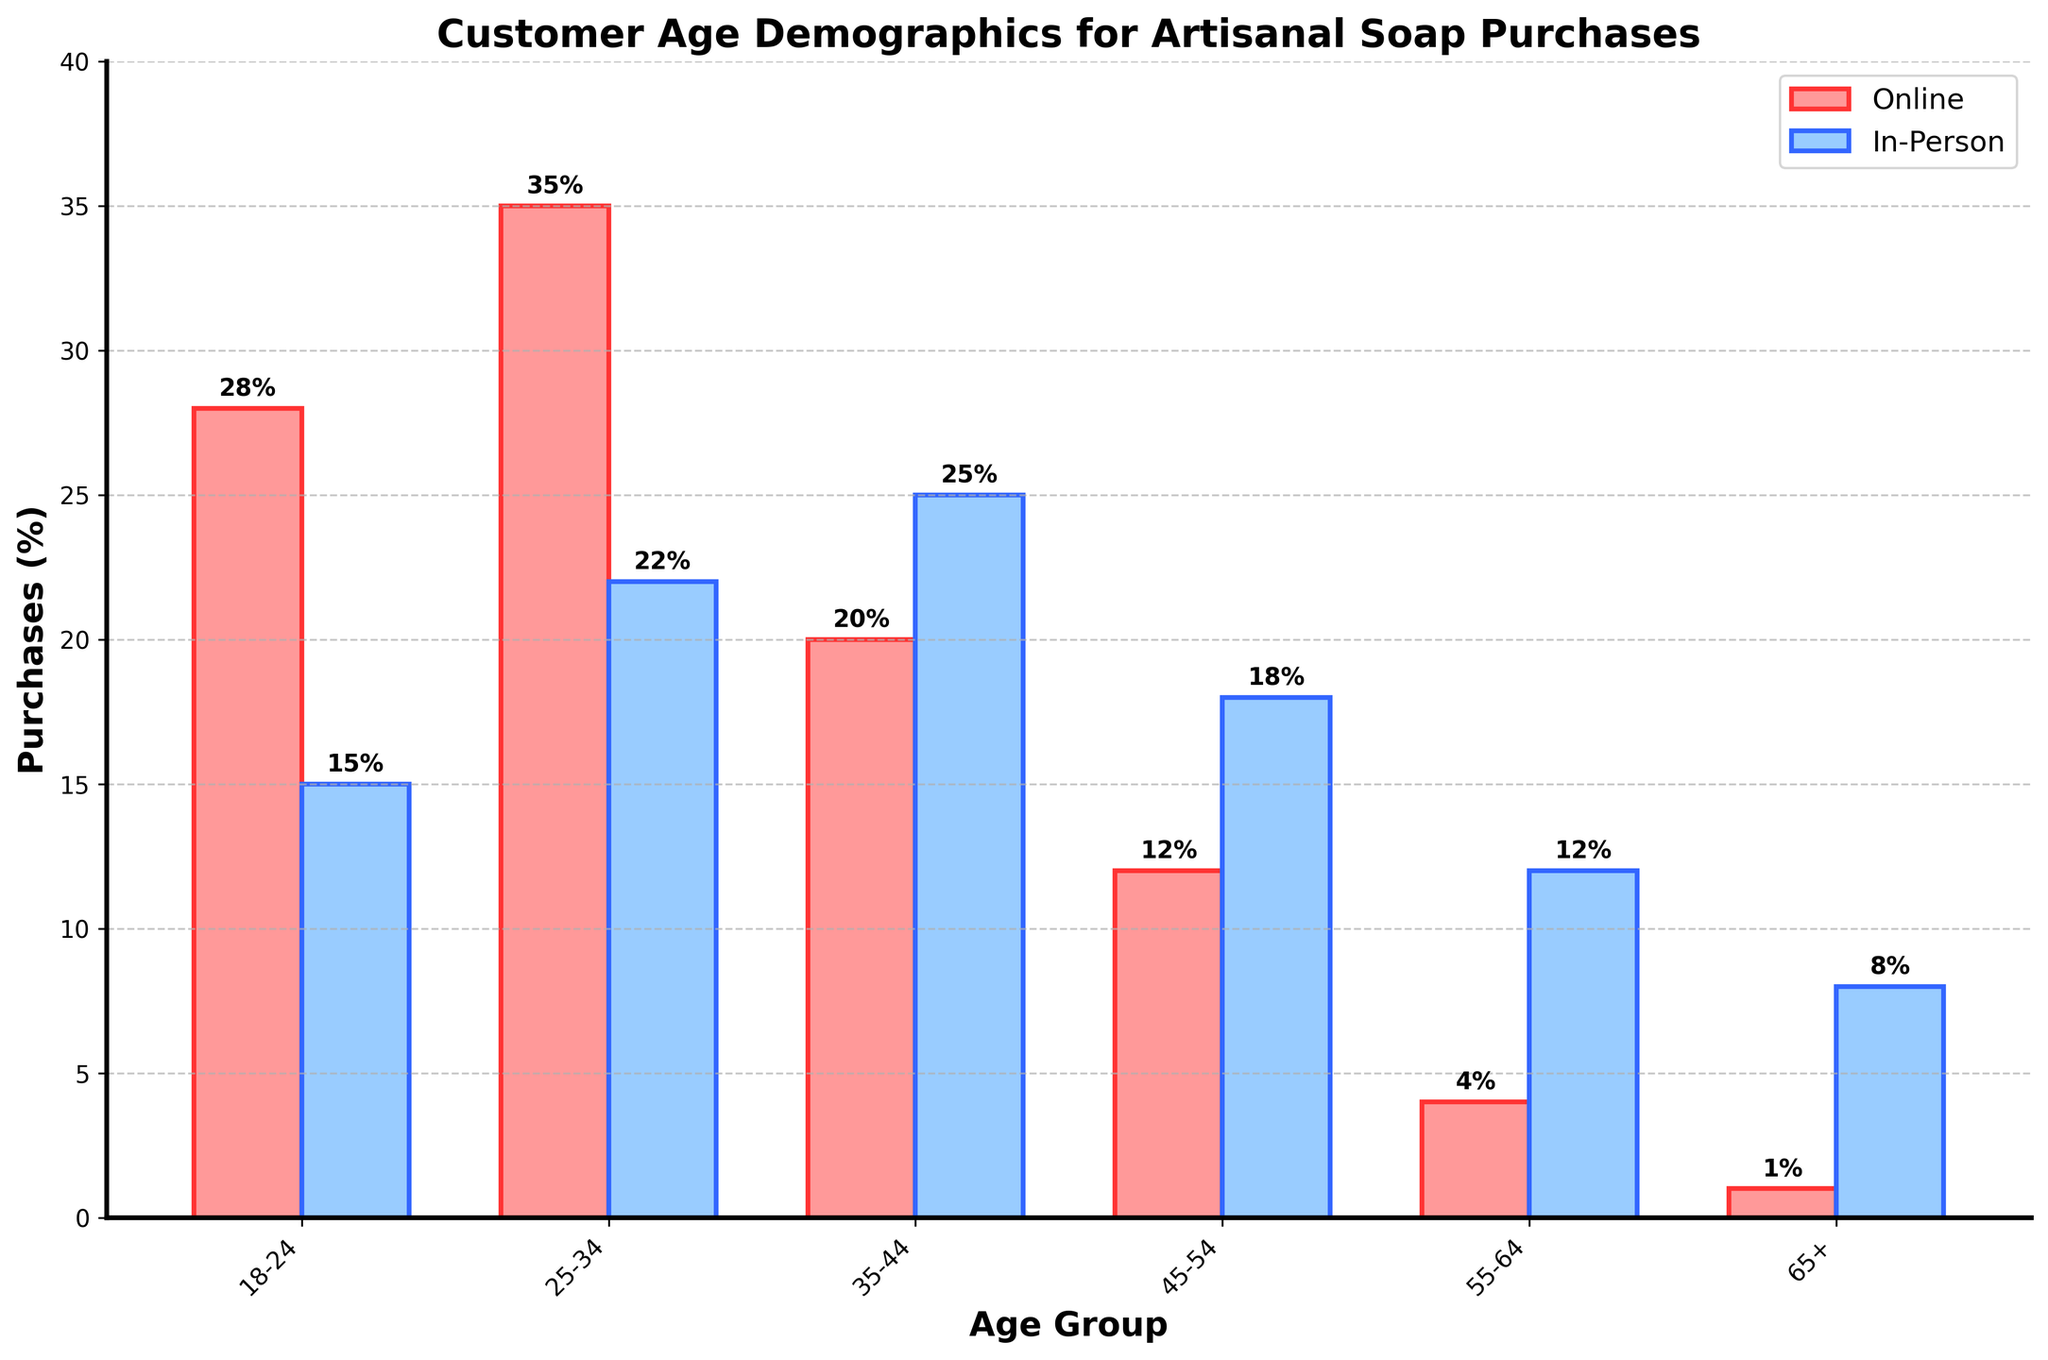What is the age group with the highest percentage of online purchases? Looking at the height of the bars representing online purchases, the 25-34 age group has the tallest bar, indicating the highest percentage.
Answer: 25-34 Which age group makes more in-person purchases compared to online purchases? By comparing each age group's bars visually, the 35-44, 45-54, 55-64, and 65+ age groups have taller in-person purchase bars than online purchase bars.
Answer: 35-44, 45-54, 55-64, 65+ How much greater is the percentage of online purchases for the 25-34 age group compared to the 18-24 age group? The online purchase percentage for 25-34 is 35%, while for 18-24 it is 28%. The difference is 35% - 28% = 7%.
Answer: 7% What is the total percentage of combined (online and in-person) purchases for the 35-44 age group? Adding both online (20%) and in-person (25%) purchases for the 35-44 age group results in a combined total: 20% + 25% = 45%.
Answer: 45% In which age group is the difference between online and in-person purchases the smallest? Observing the height differences between the paired bars for each age group, the 45-54 age group has a relatively close percentage for online (12%) and in-person (18%) purchases. The difference is 6%.
Answer: 45-54 Which age group shows the least interest in online purchases? The height of the bars representing online purchases shows that the 65+ age group has the smallest bar, at 1%.
Answer: 65+ How does the in-person purchase percentage for the 55-64 age group compare to the online purchase percentage for the same group? The online purchase for the 55-64 age group is 4%, while in-person is 12%. Comparing these, in-person purchases are greater by 12% - 4% = 8%.
Answer: In-person is 8% greater What is the average percentage of online purchases across all age groups? Summing all online purchase percentages (28%, 35%, 20%, 12%, 4%, 1%) gives 100%. Dividing by the number of age groups (6) gives an average: 100% / 6 ≈ 16.67%.
Answer: 16.67% For which age group does the difference between online and in-person purchases exceed 20 percentage points? Checking the height difference of the bars, the 18-24 age group shows a significant difference: Online (28%) and In-Person (15%). The difference is 28% - 15% = 13%. None of the age groups exceed a 20 percentage point difference
Answer: None How does the percentage of in-person purchases change as age increases from 18-24 to 65+? Observing the trend in the heights of the blue bars representing in-person purchases, we notice an increasing trend: 18-24 (15%), 25-34 (22%), 35-44 (25%), 45-54 (18%), 55-64 (12%), 65+ (8%). The percentages increase up to 35-44, then decrease inconsistently thereafter.
Answer: Increases then decreases inconsistently 